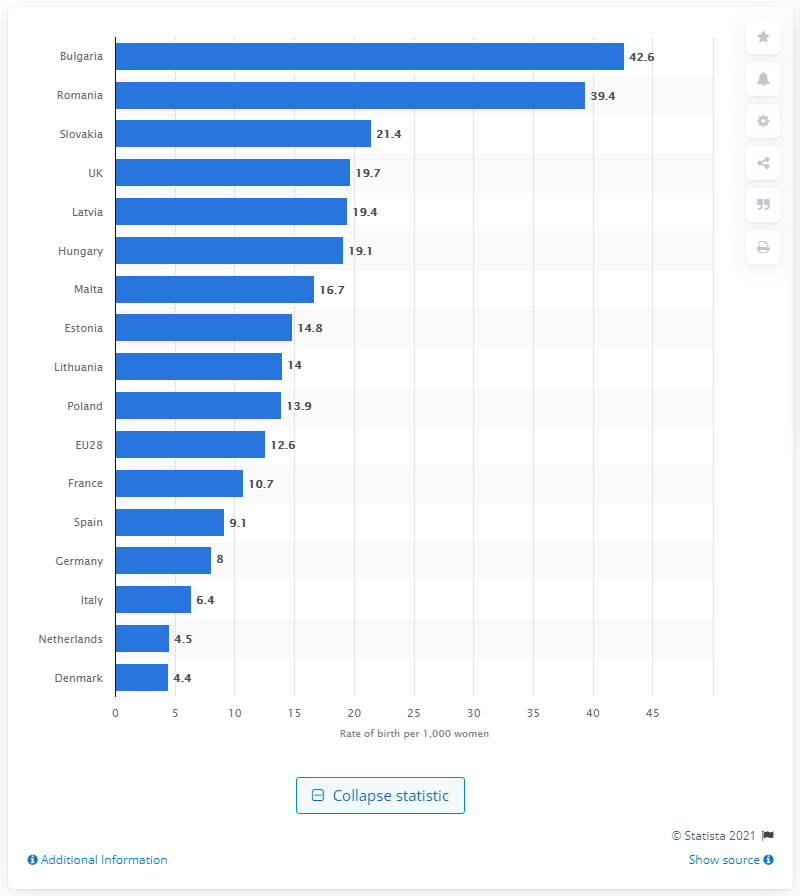List a handful of essential elements in this visual. In 2012, the live birth rate per 1,000 women in Bulgaria was 42.6. 